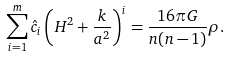Convert formula to latex. <formula><loc_0><loc_0><loc_500><loc_500>\sum ^ { m } _ { i = 1 } \hat { c } _ { i } \left ( H ^ { 2 } + \frac { k } { a ^ { 2 } } \right ) ^ { i } = \frac { 1 6 \pi G } { n ( n - 1 ) } \rho .</formula> 